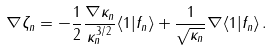Convert formula to latex. <formula><loc_0><loc_0><loc_500><loc_500>\nabla \zeta _ { n } = - \frac { 1 } { 2 } \frac { \nabla \kappa _ { n } } { \kappa _ { n } ^ { 3 / 2 } } \langle 1 | f _ { n } \rangle + \frac { 1 } { \sqrt { \kappa _ { n } } } \nabla \langle 1 | f _ { n } \rangle \, .</formula> 